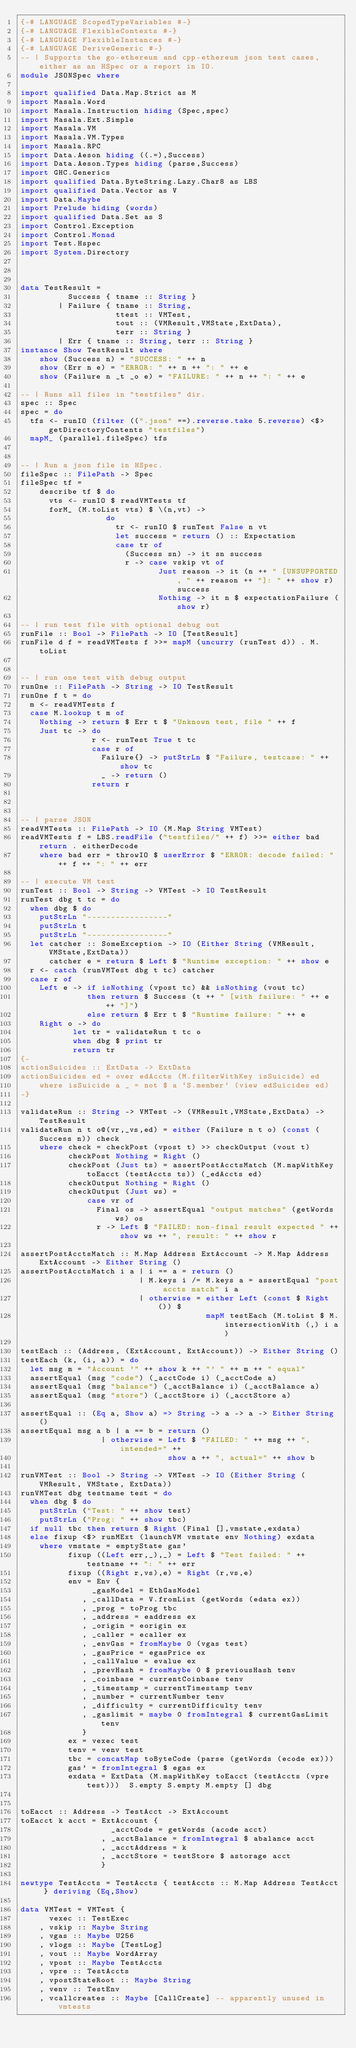Convert code to text. <code><loc_0><loc_0><loc_500><loc_500><_Haskell_>{-# LANGUAGE ScopedTypeVariables #-}
{-# LANGUAGE FlexibleContexts #-}
{-# LANGUAGE FlexibleInstances #-}
{-# LANGUAGE DeriveGeneric #-}
-- | Supports the go-ethereum and cpp-ethereum json test cases, either as an HSpec or a report in IO.
module JSONSpec where

import qualified Data.Map.Strict as M
import Masala.Word
import Masala.Instruction hiding (Spec,spec)
import Masala.Ext.Simple
import Masala.VM
import Masala.VM.Types
import Masala.RPC
import Data.Aeson hiding ((.=),Success)
import Data.Aeson.Types hiding (parse,Success)
import GHC.Generics
import qualified Data.ByteString.Lazy.Char8 as LBS
import qualified Data.Vector as V
import Data.Maybe
import Prelude hiding (words)
import qualified Data.Set as S
import Control.Exception
import Control.Monad
import Test.Hspec
import System.Directory



data TestResult =
          Success { tname :: String }
        | Failure { tname :: String,
                    ttest :: VMTest,
                    tout :: (VMResult,VMState,ExtData),
                    terr :: String }
        | Err { tname :: String, terr :: String }
instance Show TestResult where
    show (Success n) = "SUCCESS: " ++ n
    show (Err n e) = "ERROR: " ++ n ++ ": " ++ e
    show (Failure n _t _o e) = "FAILURE: " ++ n ++ ": " ++ e

-- | Runs all files in "testfiles" dir.
spec :: Spec
spec = do
  tfs <- runIO (filter ((".json" ==).reverse.take 5.reverse) <$> getDirectoryContents "testfiles")
  mapM_ (parallel.fileSpec) tfs


-- | Run a json file in HSpec.
fileSpec :: FilePath -> Spec
fileSpec tf =
    describe tf $ do
      vts <- runIO $ readVMTests tf
      forM_ (M.toList vts) $ \(n,vt) ->
                  do
                    tr <- runIO $ runTest False n vt
                    let success = return () :: Expectation
                    case tr of
                      (Success sn) -> it sn success
                      r -> case vskip vt of
                             Just reason -> it (n ++ " [UNSUPPORTED, " ++ reason ++ "]: " ++ show r) success
                             Nothing -> it n $ expectationFailure (show r)

-- | run test file with optional debug out
runFile :: Bool -> FilePath -> IO [TestResult]
runFile d f = readVMTests f >>= mapM (uncurry (runTest d)) . M.toList


-- | run one test with debug output
runOne :: FilePath -> String -> IO TestResult
runOne f t = do
  m <- readVMTests f
  case M.lookup t m of
    Nothing -> return $ Err t $ "Unknown test, file " ++ f
    Just tc -> do
               r <- runTest True t tc
               case r of
                 Failure{} -> putStrLn $ "Failure, testcase: " ++ show tc
                 _ -> return ()
               return r



-- | parse JSON
readVMTests :: FilePath -> IO (M.Map String VMTest)
readVMTests f = LBS.readFile ("testfiles/" ++ f) >>= either bad return . eitherDecode
    where bad err = throwIO $ userError $ "ERROR: decode failed: " ++ f ++ ": " ++ err

-- | execute VM test
runTest :: Bool -> String -> VMTest -> IO TestResult
runTest dbg t tc = do
  when dbg $ do
    putStrLn "-----------------"
    putStrLn t
    putStrLn "-----------------"
  let catcher :: SomeException -> IO (Either String (VMResult,VMState,ExtData))
      catcher e = return $ Left $ "Runtime exception: " ++ show e
  r <- catch (runVMTest dbg t tc) catcher
  case r of
    Left e -> if isNothing (vpost tc) && isNothing (vout tc)
              then return $ Success (t ++ " [with failure: " ++ e ++ "]")
              else return $ Err t $ "Runtime failure: " ++ e
    Right o -> do
           let tr = validateRun t tc o
           when dbg $ print tr
           return tr
{-
actionSuicides :: ExtData -> ExtData
actionSuicides ed = over edAccts (M.filterWithKey isSuicide) ed
    where isSuicide a _ = not $ a `S.member` (view edSuicides ed)
-}

validateRun :: String -> VMTest -> (VMResult,VMState,ExtData) -> TestResult
validateRun n t o@(vr,_vs,ed) = either (Failure n t o) (const (Success n)) check
    where check = checkPost (vpost t) >> checkOutput (vout t)
          checkPost Nothing = Right ()
          checkPost (Just ts) = assertPostAcctsMatch (M.mapWithKey toEacct (testAccts ts)) (_edAccts ed)
          checkOutput Nothing = Right ()
          checkOutput (Just ws) =
              case vr of
                Final os -> assertEqual "output matches" (getWords ws) os
                r -> Left $ "FAILED: non-final result expected " ++ show ws ++ ", result: " ++ show r

assertPostAcctsMatch :: M.Map Address ExtAccount -> M.Map Address ExtAccount -> Either String ()
assertPostAcctsMatch i a | i == a = return ()
                         | M.keys i /= M.keys a = assertEqual "post accts match" i a
                         | otherwise = either Left (const $ Right ()) $
                                       mapM testEach (M.toList $ M.intersectionWith (,) i a)

testEach :: (Address, (ExtAccount, ExtAccount)) -> Either String ()
testEach (k, (i, a)) = do
  let msg m = "Account '" ++ show k ++ "' " ++ m ++ " equal"
  assertEqual (msg "code") (_acctCode i) (_acctCode a)
  assertEqual (msg "balance") (_acctBalance i) (_acctBalance a)
  assertEqual (msg "store") (_acctStore i) (_acctStore a)

assertEqual :: (Eq a, Show a) => String -> a -> a -> Either String ()
assertEqual msg a b | a == b = return ()
                 | otherwise = Left $ "FAILED: " ++ msg ++ ", intended=" ++
                               show a ++ ", actual=" ++ show b

runVMTest :: Bool -> String -> VMTest -> IO (Either String (VMResult, VMState, ExtData))
runVMTest dbg testname test = do
  when dbg $ do
    putStrLn ("Test: " ++ show test)
    putStrLn ("Prog: " ++ show tbc)
  if null tbc then return $ Right (Final [],vmstate,exdata)
  else fixup <$> runMExt (launchVM vmstate env Nothing) exdata
    where vmstate = emptyState gas'
          fixup ((Left err,_),_) = Left $ "Test failed: " ++ testname ++ ": " ++ err
          fixup ((Right r,vs),e) = Right (r,vs,e)
          env = Env {
               _gasModel = EthGasModel
             , _callData = V.fromList (getWords (edata ex))
             , _prog = toProg tbc
             , _address = eaddress ex
             , _origin = eorigin ex
             , _caller = ecaller ex
             , _envGas = fromMaybe 0 (vgas test)
             , _gasPrice = egasPrice ex
             , _callValue = evalue ex
             , _prevHash = fromMaybe 0 $ previousHash tenv
             , _coinbase = currentCoinbase tenv
             , _timestamp = currentTimestamp tenv
             , _number = currentNumber tenv
             , _difficulty = currentDifficulty tenv
             , _gaslimit = maybe 0 fromIntegral $ currentGasLimit tenv
             }
          ex = vexec test
          tenv = venv test
          tbc = concatMap toByteCode (parse (getWords (ecode ex)))
          gas' = fromIntegral $ egas ex
          exdata = ExtData (M.mapWithKey toEacct (testAccts (vpre test)))  S.empty S.empty M.empty [] dbg


toEacct :: Address -> TestAcct -> ExtAccount
toEacct k acct = ExtAccount {
                   _acctCode = getWords (acode acct)
                 , _acctBalance = fromIntegral $ abalance acct
                 , _acctAddress = k
                 , _acctStore = testStore $ astorage acct
                 }

newtype TestAccts = TestAccts { testAccts :: M.Map Address TestAcct } deriving (Eq,Show)

data VMTest = VMTest {
      vexec :: TestExec
    , vskip :: Maybe String
    , vgas :: Maybe U256
    , vlogs :: Maybe [TestLog]
    , vout :: Maybe WordArray
    , vpost :: Maybe TestAccts
    , vpre :: TestAccts
    , vpostStateRoot :: Maybe String
    , venv :: TestEnv
    , vcallcreates :: Maybe [CallCreate] -- apparently unused in vmtests</code> 